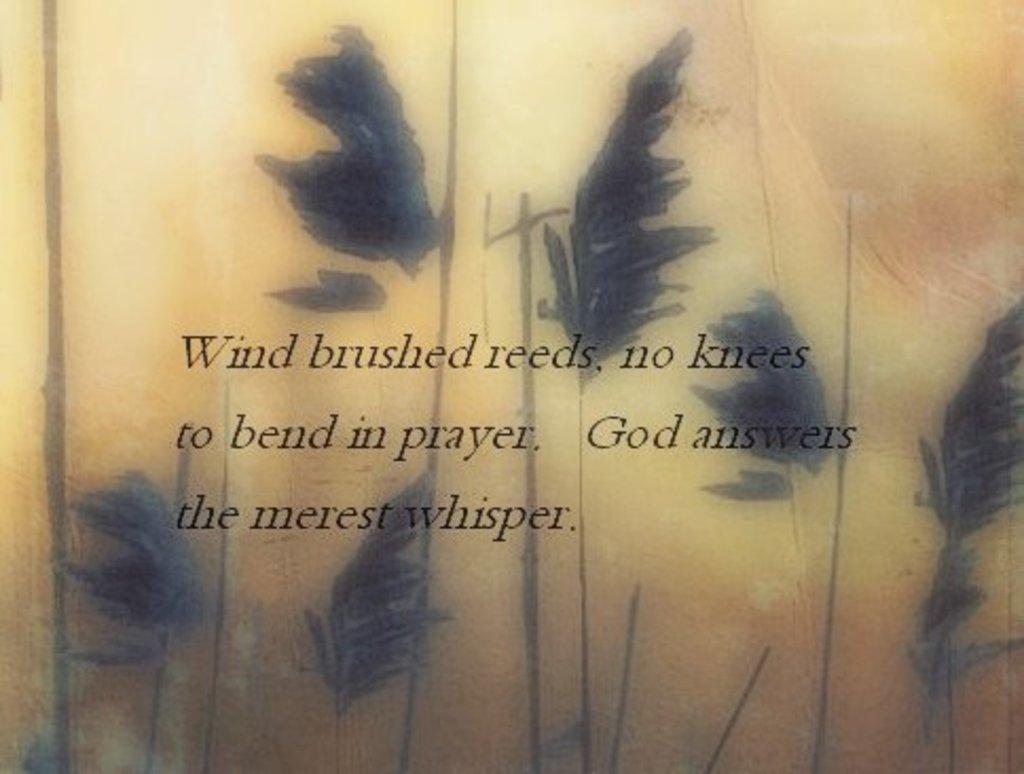Describe this image in one or two sentences. This is a zoomed in picture. In the center there is an object seems to be the paper on which we can see the picture of some leaves and the text is printed on the paper. 